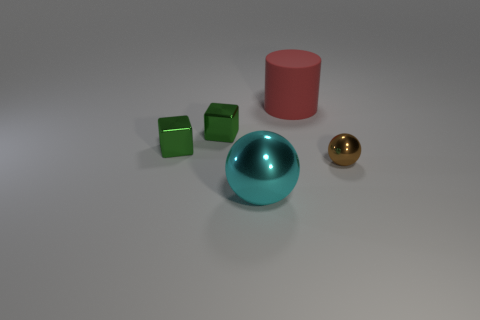What shades are present in the image besides the objects themselves? Aside from the colored objects, the image features a gradient of light grey to white on the floor, which could be indicating a light source above the scene, and the background is uniformly grey.  Could you create a short story based on these objects? In a quaint corner of a toy designer's studio, a pair of twin green dice await their turn to be part of a new board game. Beside them, a pink cylinder -- the pillar of their tiny community -- stands tall, casting a soft shadow. The regal cyan sphere, with its gleaming surface, often rolls around telling tales of the times it reflected the room's joyful lights. Meanwhile, the small, golden sphere listens intently, dreaming of the day it becomes the treasured centerpiece in a child's collection of marbles. 